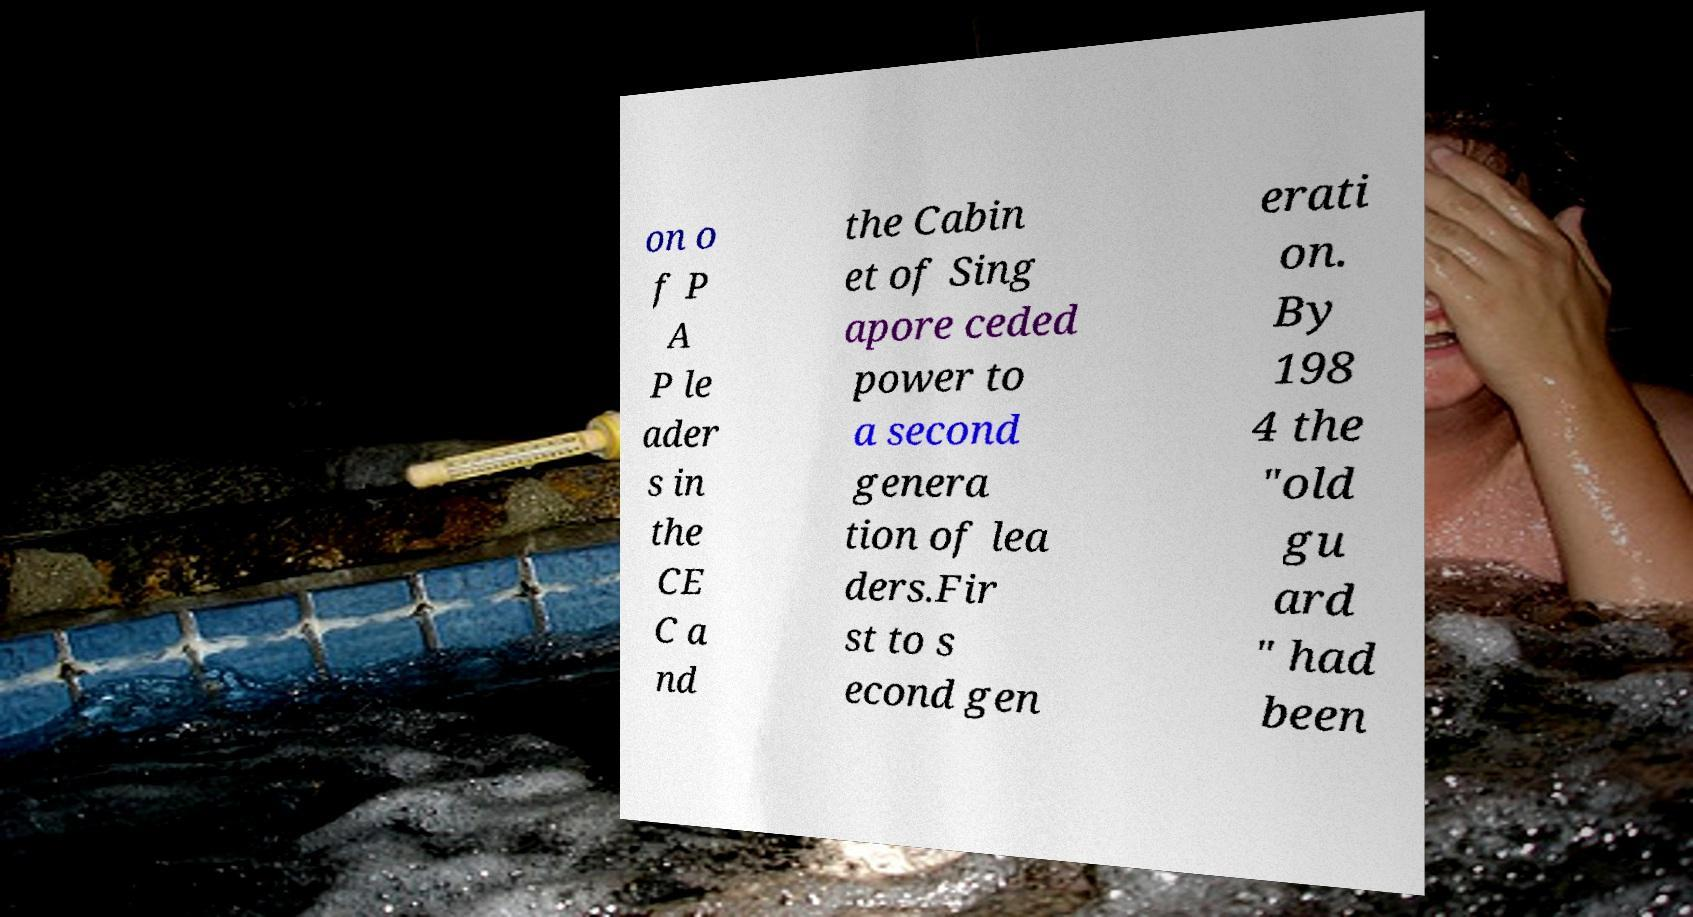Please identify and transcribe the text found in this image. on o f P A P le ader s in the CE C a nd the Cabin et of Sing apore ceded power to a second genera tion of lea ders.Fir st to s econd gen erati on. By 198 4 the "old gu ard " had been 